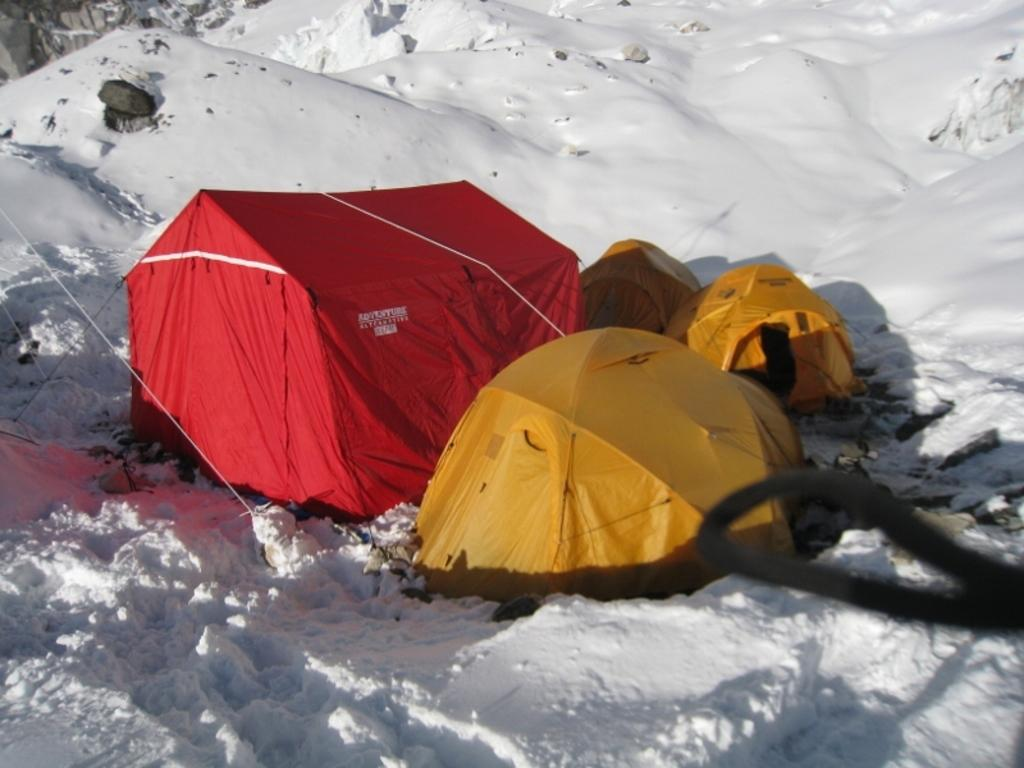What colors are the stands in the image? The stands in the image are red and yellow. Where are the stands located? The stands are on the ground. What type of weather condition is depicted in the image? There is snow visible at the bottom of the image, indicating a snowy condition. What geographical feature can be seen in the image? There is a mountain in the image. What type of material is present in the image? Stones are present in the image. What type of ring can be seen on the mountain in the image? There is no ring present on the mountain in the image. How many letters are visible on the stands in the image? There is no information about letters on the stands in the image. 